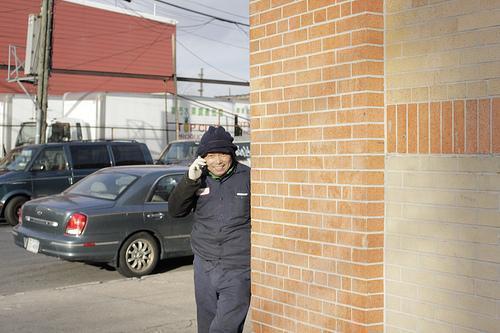How many people are seen?
Give a very brief answer. 1. 